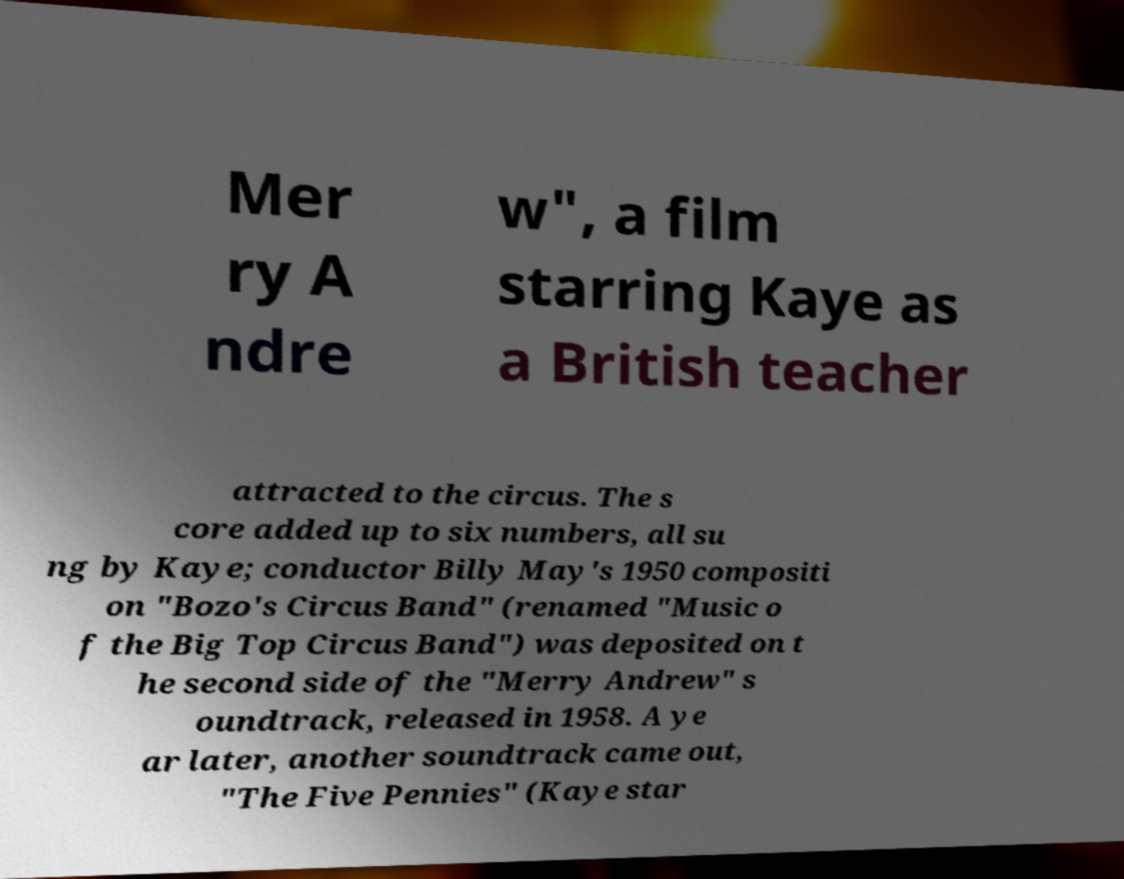I need the written content from this picture converted into text. Can you do that? Mer ry A ndre w", a film starring Kaye as a British teacher attracted to the circus. The s core added up to six numbers, all su ng by Kaye; conductor Billy May's 1950 compositi on "Bozo's Circus Band" (renamed "Music o f the Big Top Circus Band") was deposited on t he second side of the "Merry Andrew" s oundtrack, released in 1958. A ye ar later, another soundtrack came out, "The Five Pennies" (Kaye star 